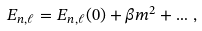Convert formula to latex. <formula><loc_0><loc_0><loc_500><loc_500>E _ { n , \ell } = E _ { n , \ell } ( 0 ) + \beta m ^ { 2 } + \dots \, ,</formula> 